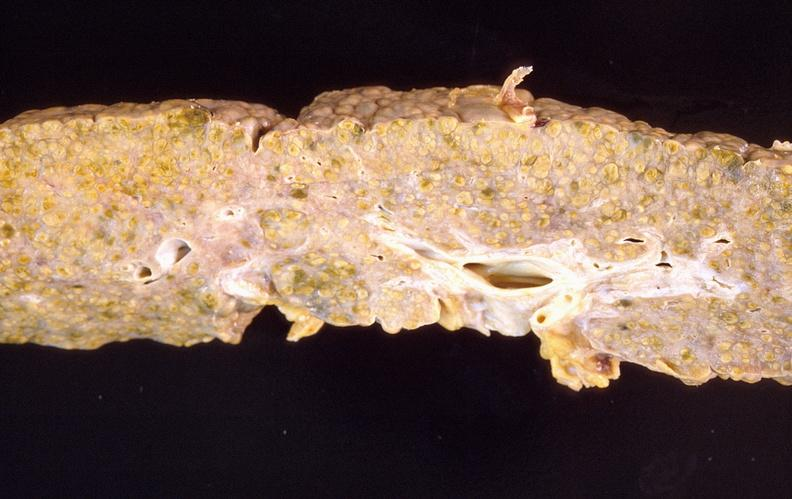what is present?
Answer the question using a single word or phrase. Hepatobiliary 